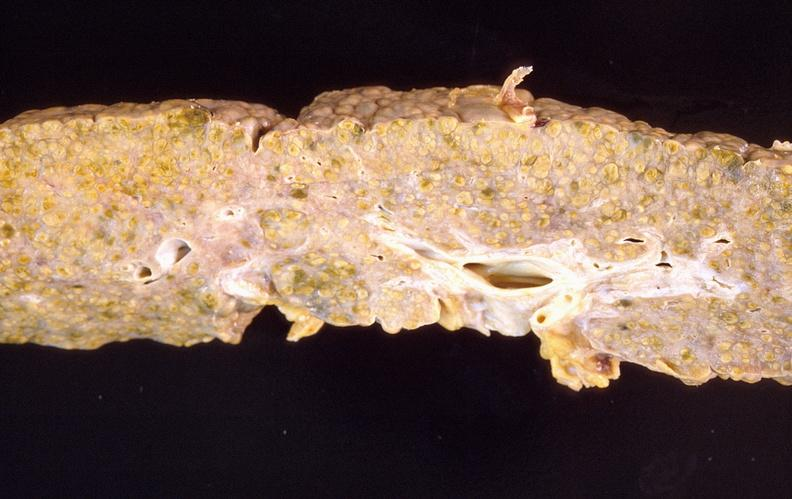what is present?
Answer the question using a single word or phrase. Hepatobiliary 